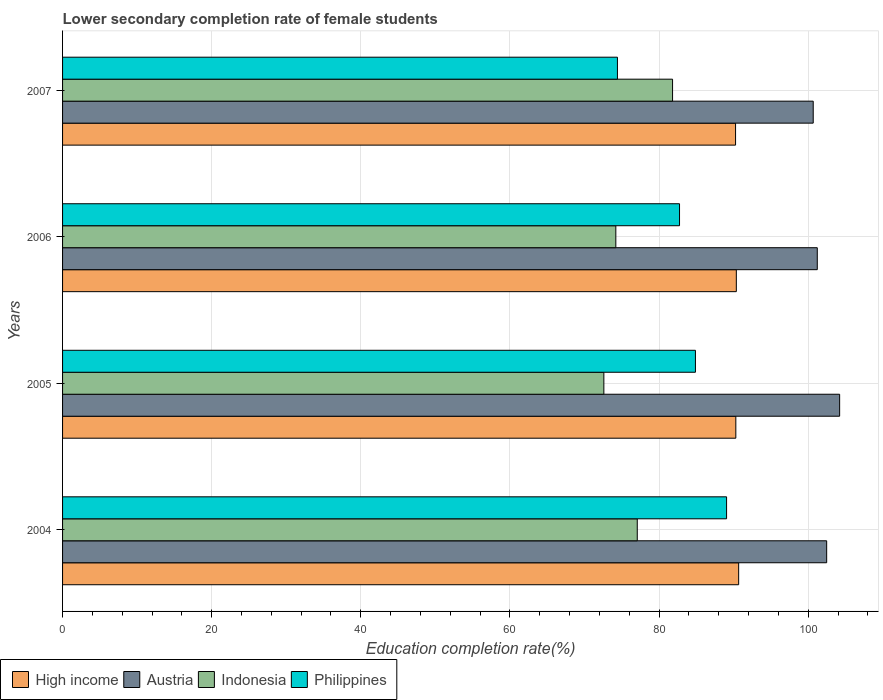How many bars are there on the 1st tick from the bottom?
Provide a succinct answer. 4. What is the label of the 1st group of bars from the top?
Your answer should be compact. 2007. What is the lower secondary completion rate of female students in Austria in 2004?
Your answer should be compact. 102.48. Across all years, what is the maximum lower secondary completion rate of female students in High income?
Provide a short and direct response. 90.67. Across all years, what is the minimum lower secondary completion rate of female students in Philippines?
Ensure brevity in your answer.  74.42. In which year was the lower secondary completion rate of female students in High income maximum?
Give a very brief answer. 2004. What is the total lower secondary completion rate of female students in High income in the graph?
Offer a terse response. 361.6. What is the difference between the lower secondary completion rate of female students in Philippines in 2004 and that in 2007?
Provide a succinct answer. 14.64. What is the difference between the lower secondary completion rate of female students in High income in 2004 and the lower secondary completion rate of female students in Indonesia in 2005?
Keep it short and to the point. 18.08. What is the average lower secondary completion rate of female students in High income per year?
Your answer should be compact. 90.4. In the year 2004, what is the difference between the lower secondary completion rate of female students in Indonesia and lower secondary completion rate of female students in Philippines?
Provide a succinct answer. -11.98. In how many years, is the lower secondary completion rate of female students in Philippines greater than 12 %?
Your response must be concise. 4. What is the ratio of the lower secondary completion rate of female students in Indonesia in 2004 to that in 2005?
Your answer should be very brief. 1.06. Is the lower secondary completion rate of female students in Austria in 2004 less than that in 2006?
Give a very brief answer. No. What is the difference between the highest and the second highest lower secondary completion rate of female students in Philippines?
Provide a succinct answer. 4.18. What is the difference between the highest and the lowest lower secondary completion rate of female students in Indonesia?
Make the answer very short. 9.21. Is the sum of the lower secondary completion rate of female students in High income in 2005 and 2007 greater than the maximum lower secondary completion rate of female students in Indonesia across all years?
Provide a succinct answer. Yes. What does the 3rd bar from the bottom in 2004 represents?
Provide a short and direct response. Indonesia. Is it the case that in every year, the sum of the lower secondary completion rate of female students in Austria and lower secondary completion rate of female students in High income is greater than the lower secondary completion rate of female students in Indonesia?
Provide a succinct answer. Yes. How many bars are there?
Provide a short and direct response. 16. Are the values on the major ticks of X-axis written in scientific E-notation?
Ensure brevity in your answer.  No. Does the graph contain any zero values?
Your response must be concise. No. Does the graph contain grids?
Keep it short and to the point. Yes. What is the title of the graph?
Provide a succinct answer. Lower secondary completion rate of female students. What is the label or title of the X-axis?
Provide a short and direct response. Education completion rate(%). What is the Education completion rate(%) of High income in 2004?
Your response must be concise. 90.67. What is the Education completion rate(%) of Austria in 2004?
Offer a very short reply. 102.48. What is the Education completion rate(%) of Indonesia in 2004?
Offer a very short reply. 77.08. What is the Education completion rate(%) of Philippines in 2004?
Offer a terse response. 89.05. What is the Education completion rate(%) of High income in 2005?
Keep it short and to the point. 90.3. What is the Education completion rate(%) of Austria in 2005?
Provide a short and direct response. 104.22. What is the Education completion rate(%) of Indonesia in 2005?
Provide a succinct answer. 72.6. What is the Education completion rate(%) in Philippines in 2005?
Your response must be concise. 84.88. What is the Education completion rate(%) in High income in 2006?
Ensure brevity in your answer.  90.36. What is the Education completion rate(%) of Austria in 2006?
Your response must be concise. 101.22. What is the Education completion rate(%) in Indonesia in 2006?
Your response must be concise. 74.2. What is the Education completion rate(%) of Philippines in 2006?
Your answer should be very brief. 82.75. What is the Education completion rate(%) in High income in 2007?
Your answer should be compact. 90.26. What is the Education completion rate(%) of Austria in 2007?
Ensure brevity in your answer.  100.68. What is the Education completion rate(%) in Indonesia in 2007?
Provide a short and direct response. 81.81. What is the Education completion rate(%) of Philippines in 2007?
Give a very brief answer. 74.42. Across all years, what is the maximum Education completion rate(%) of High income?
Your answer should be very brief. 90.67. Across all years, what is the maximum Education completion rate(%) of Austria?
Offer a terse response. 104.22. Across all years, what is the maximum Education completion rate(%) in Indonesia?
Give a very brief answer. 81.81. Across all years, what is the maximum Education completion rate(%) of Philippines?
Your response must be concise. 89.05. Across all years, what is the minimum Education completion rate(%) in High income?
Your answer should be very brief. 90.26. Across all years, what is the minimum Education completion rate(%) in Austria?
Offer a terse response. 100.68. Across all years, what is the minimum Education completion rate(%) of Indonesia?
Offer a very short reply. 72.6. Across all years, what is the minimum Education completion rate(%) of Philippines?
Ensure brevity in your answer.  74.42. What is the total Education completion rate(%) of High income in the graph?
Keep it short and to the point. 361.6. What is the total Education completion rate(%) in Austria in the graph?
Your answer should be very brief. 408.6. What is the total Education completion rate(%) in Indonesia in the graph?
Provide a short and direct response. 305.69. What is the total Education completion rate(%) in Philippines in the graph?
Ensure brevity in your answer.  331.1. What is the difference between the Education completion rate(%) of High income in 2004 and that in 2005?
Ensure brevity in your answer.  0.38. What is the difference between the Education completion rate(%) of Austria in 2004 and that in 2005?
Provide a succinct answer. -1.74. What is the difference between the Education completion rate(%) in Indonesia in 2004 and that in 2005?
Offer a very short reply. 4.48. What is the difference between the Education completion rate(%) in Philippines in 2004 and that in 2005?
Provide a succinct answer. 4.18. What is the difference between the Education completion rate(%) in High income in 2004 and that in 2006?
Offer a terse response. 0.31. What is the difference between the Education completion rate(%) of Austria in 2004 and that in 2006?
Offer a very short reply. 1.26. What is the difference between the Education completion rate(%) in Indonesia in 2004 and that in 2006?
Provide a succinct answer. 2.88. What is the difference between the Education completion rate(%) of Philippines in 2004 and that in 2006?
Offer a terse response. 6.31. What is the difference between the Education completion rate(%) of High income in 2004 and that in 2007?
Keep it short and to the point. 0.41. What is the difference between the Education completion rate(%) of Austria in 2004 and that in 2007?
Offer a very short reply. 1.8. What is the difference between the Education completion rate(%) of Indonesia in 2004 and that in 2007?
Give a very brief answer. -4.73. What is the difference between the Education completion rate(%) of Philippines in 2004 and that in 2007?
Offer a terse response. 14.64. What is the difference between the Education completion rate(%) in High income in 2005 and that in 2006?
Give a very brief answer. -0.07. What is the difference between the Education completion rate(%) of Austria in 2005 and that in 2006?
Give a very brief answer. 3. What is the difference between the Education completion rate(%) in Indonesia in 2005 and that in 2006?
Keep it short and to the point. -1.6. What is the difference between the Education completion rate(%) in Philippines in 2005 and that in 2006?
Provide a short and direct response. 2.13. What is the difference between the Education completion rate(%) in High income in 2005 and that in 2007?
Give a very brief answer. 0.03. What is the difference between the Education completion rate(%) in Austria in 2005 and that in 2007?
Your response must be concise. 3.54. What is the difference between the Education completion rate(%) of Indonesia in 2005 and that in 2007?
Your answer should be very brief. -9.21. What is the difference between the Education completion rate(%) in Philippines in 2005 and that in 2007?
Give a very brief answer. 10.46. What is the difference between the Education completion rate(%) of High income in 2006 and that in 2007?
Provide a short and direct response. 0.1. What is the difference between the Education completion rate(%) of Austria in 2006 and that in 2007?
Keep it short and to the point. 0.54. What is the difference between the Education completion rate(%) of Indonesia in 2006 and that in 2007?
Ensure brevity in your answer.  -7.61. What is the difference between the Education completion rate(%) in Philippines in 2006 and that in 2007?
Offer a very short reply. 8.33. What is the difference between the Education completion rate(%) in High income in 2004 and the Education completion rate(%) in Austria in 2005?
Ensure brevity in your answer.  -13.54. What is the difference between the Education completion rate(%) in High income in 2004 and the Education completion rate(%) in Indonesia in 2005?
Give a very brief answer. 18.08. What is the difference between the Education completion rate(%) of High income in 2004 and the Education completion rate(%) of Philippines in 2005?
Your response must be concise. 5.8. What is the difference between the Education completion rate(%) of Austria in 2004 and the Education completion rate(%) of Indonesia in 2005?
Your response must be concise. 29.88. What is the difference between the Education completion rate(%) of Austria in 2004 and the Education completion rate(%) of Philippines in 2005?
Make the answer very short. 17.6. What is the difference between the Education completion rate(%) in Indonesia in 2004 and the Education completion rate(%) in Philippines in 2005?
Your answer should be very brief. -7.8. What is the difference between the Education completion rate(%) in High income in 2004 and the Education completion rate(%) in Austria in 2006?
Ensure brevity in your answer.  -10.55. What is the difference between the Education completion rate(%) of High income in 2004 and the Education completion rate(%) of Indonesia in 2006?
Make the answer very short. 16.47. What is the difference between the Education completion rate(%) in High income in 2004 and the Education completion rate(%) in Philippines in 2006?
Ensure brevity in your answer.  7.93. What is the difference between the Education completion rate(%) of Austria in 2004 and the Education completion rate(%) of Indonesia in 2006?
Ensure brevity in your answer.  28.28. What is the difference between the Education completion rate(%) in Austria in 2004 and the Education completion rate(%) in Philippines in 2006?
Offer a very short reply. 19.73. What is the difference between the Education completion rate(%) in Indonesia in 2004 and the Education completion rate(%) in Philippines in 2006?
Provide a succinct answer. -5.67. What is the difference between the Education completion rate(%) in High income in 2004 and the Education completion rate(%) in Austria in 2007?
Your answer should be compact. -10. What is the difference between the Education completion rate(%) in High income in 2004 and the Education completion rate(%) in Indonesia in 2007?
Keep it short and to the point. 8.86. What is the difference between the Education completion rate(%) of High income in 2004 and the Education completion rate(%) of Philippines in 2007?
Your response must be concise. 16.26. What is the difference between the Education completion rate(%) in Austria in 2004 and the Education completion rate(%) in Indonesia in 2007?
Your answer should be very brief. 20.67. What is the difference between the Education completion rate(%) of Austria in 2004 and the Education completion rate(%) of Philippines in 2007?
Provide a succinct answer. 28.06. What is the difference between the Education completion rate(%) in Indonesia in 2004 and the Education completion rate(%) in Philippines in 2007?
Provide a short and direct response. 2.66. What is the difference between the Education completion rate(%) of High income in 2005 and the Education completion rate(%) of Austria in 2006?
Offer a terse response. -10.92. What is the difference between the Education completion rate(%) of High income in 2005 and the Education completion rate(%) of Indonesia in 2006?
Offer a very short reply. 16.09. What is the difference between the Education completion rate(%) of High income in 2005 and the Education completion rate(%) of Philippines in 2006?
Give a very brief answer. 7.55. What is the difference between the Education completion rate(%) of Austria in 2005 and the Education completion rate(%) of Indonesia in 2006?
Offer a very short reply. 30.02. What is the difference between the Education completion rate(%) in Austria in 2005 and the Education completion rate(%) in Philippines in 2006?
Ensure brevity in your answer.  21.47. What is the difference between the Education completion rate(%) of Indonesia in 2005 and the Education completion rate(%) of Philippines in 2006?
Ensure brevity in your answer.  -10.15. What is the difference between the Education completion rate(%) of High income in 2005 and the Education completion rate(%) of Austria in 2007?
Your answer should be very brief. -10.38. What is the difference between the Education completion rate(%) of High income in 2005 and the Education completion rate(%) of Indonesia in 2007?
Give a very brief answer. 8.49. What is the difference between the Education completion rate(%) in High income in 2005 and the Education completion rate(%) in Philippines in 2007?
Ensure brevity in your answer.  15.88. What is the difference between the Education completion rate(%) of Austria in 2005 and the Education completion rate(%) of Indonesia in 2007?
Offer a terse response. 22.41. What is the difference between the Education completion rate(%) in Austria in 2005 and the Education completion rate(%) in Philippines in 2007?
Your response must be concise. 29.8. What is the difference between the Education completion rate(%) in Indonesia in 2005 and the Education completion rate(%) in Philippines in 2007?
Provide a short and direct response. -1.82. What is the difference between the Education completion rate(%) of High income in 2006 and the Education completion rate(%) of Austria in 2007?
Make the answer very short. -10.31. What is the difference between the Education completion rate(%) of High income in 2006 and the Education completion rate(%) of Indonesia in 2007?
Your response must be concise. 8.55. What is the difference between the Education completion rate(%) in High income in 2006 and the Education completion rate(%) in Philippines in 2007?
Offer a very short reply. 15.95. What is the difference between the Education completion rate(%) of Austria in 2006 and the Education completion rate(%) of Indonesia in 2007?
Give a very brief answer. 19.41. What is the difference between the Education completion rate(%) in Austria in 2006 and the Education completion rate(%) in Philippines in 2007?
Make the answer very short. 26.8. What is the difference between the Education completion rate(%) in Indonesia in 2006 and the Education completion rate(%) in Philippines in 2007?
Keep it short and to the point. -0.22. What is the average Education completion rate(%) in High income per year?
Keep it short and to the point. 90.4. What is the average Education completion rate(%) of Austria per year?
Your answer should be very brief. 102.15. What is the average Education completion rate(%) in Indonesia per year?
Ensure brevity in your answer.  76.42. What is the average Education completion rate(%) in Philippines per year?
Make the answer very short. 82.77. In the year 2004, what is the difference between the Education completion rate(%) in High income and Education completion rate(%) in Austria?
Give a very brief answer. -11.81. In the year 2004, what is the difference between the Education completion rate(%) of High income and Education completion rate(%) of Indonesia?
Provide a short and direct response. 13.6. In the year 2004, what is the difference between the Education completion rate(%) of High income and Education completion rate(%) of Philippines?
Make the answer very short. 1.62. In the year 2004, what is the difference between the Education completion rate(%) of Austria and Education completion rate(%) of Indonesia?
Offer a very short reply. 25.4. In the year 2004, what is the difference between the Education completion rate(%) of Austria and Education completion rate(%) of Philippines?
Make the answer very short. 13.43. In the year 2004, what is the difference between the Education completion rate(%) in Indonesia and Education completion rate(%) in Philippines?
Offer a terse response. -11.98. In the year 2005, what is the difference between the Education completion rate(%) in High income and Education completion rate(%) in Austria?
Ensure brevity in your answer.  -13.92. In the year 2005, what is the difference between the Education completion rate(%) of High income and Education completion rate(%) of Indonesia?
Give a very brief answer. 17.7. In the year 2005, what is the difference between the Education completion rate(%) in High income and Education completion rate(%) in Philippines?
Keep it short and to the point. 5.42. In the year 2005, what is the difference between the Education completion rate(%) of Austria and Education completion rate(%) of Indonesia?
Give a very brief answer. 31.62. In the year 2005, what is the difference between the Education completion rate(%) in Austria and Education completion rate(%) in Philippines?
Offer a terse response. 19.34. In the year 2005, what is the difference between the Education completion rate(%) of Indonesia and Education completion rate(%) of Philippines?
Ensure brevity in your answer.  -12.28. In the year 2006, what is the difference between the Education completion rate(%) in High income and Education completion rate(%) in Austria?
Give a very brief answer. -10.86. In the year 2006, what is the difference between the Education completion rate(%) in High income and Education completion rate(%) in Indonesia?
Your response must be concise. 16.16. In the year 2006, what is the difference between the Education completion rate(%) in High income and Education completion rate(%) in Philippines?
Your answer should be compact. 7.62. In the year 2006, what is the difference between the Education completion rate(%) of Austria and Education completion rate(%) of Indonesia?
Provide a succinct answer. 27.02. In the year 2006, what is the difference between the Education completion rate(%) in Austria and Education completion rate(%) in Philippines?
Keep it short and to the point. 18.47. In the year 2006, what is the difference between the Education completion rate(%) in Indonesia and Education completion rate(%) in Philippines?
Provide a succinct answer. -8.54. In the year 2007, what is the difference between the Education completion rate(%) of High income and Education completion rate(%) of Austria?
Ensure brevity in your answer.  -10.41. In the year 2007, what is the difference between the Education completion rate(%) in High income and Education completion rate(%) in Indonesia?
Ensure brevity in your answer.  8.45. In the year 2007, what is the difference between the Education completion rate(%) in High income and Education completion rate(%) in Philippines?
Provide a short and direct response. 15.84. In the year 2007, what is the difference between the Education completion rate(%) of Austria and Education completion rate(%) of Indonesia?
Offer a terse response. 18.86. In the year 2007, what is the difference between the Education completion rate(%) of Austria and Education completion rate(%) of Philippines?
Offer a very short reply. 26.26. In the year 2007, what is the difference between the Education completion rate(%) of Indonesia and Education completion rate(%) of Philippines?
Make the answer very short. 7.39. What is the ratio of the Education completion rate(%) of Austria in 2004 to that in 2005?
Ensure brevity in your answer.  0.98. What is the ratio of the Education completion rate(%) in Indonesia in 2004 to that in 2005?
Keep it short and to the point. 1.06. What is the ratio of the Education completion rate(%) of Philippines in 2004 to that in 2005?
Offer a very short reply. 1.05. What is the ratio of the Education completion rate(%) of Austria in 2004 to that in 2006?
Provide a short and direct response. 1.01. What is the ratio of the Education completion rate(%) of Indonesia in 2004 to that in 2006?
Make the answer very short. 1.04. What is the ratio of the Education completion rate(%) in Philippines in 2004 to that in 2006?
Provide a succinct answer. 1.08. What is the ratio of the Education completion rate(%) in Austria in 2004 to that in 2007?
Your answer should be compact. 1.02. What is the ratio of the Education completion rate(%) in Indonesia in 2004 to that in 2007?
Offer a very short reply. 0.94. What is the ratio of the Education completion rate(%) of Philippines in 2004 to that in 2007?
Make the answer very short. 1.2. What is the ratio of the Education completion rate(%) of Austria in 2005 to that in 2006?
Ensure brevity in your answer.  1.03. What is the ratio of the Education completion rate(%) in Indonesia in 2005 to that in 2006?
Provide a short and direct response. 0.98. What is the ratio of the Education completion rate(%) in Philippines in 2005 to that in 2006?
Offer a very short reply. 1.03. What is the ratio of the Education completion rate(%) in Austria in 2005 to that in 2007?
Your answer should be very brief. 1.04. What is the ratio of the Education completion rate(%) in Indonesia in 2005 to that in 2007?
Provide a short and direct response. 0.89. What is the ratio of the Education completion rate(%) in Philippines in 2005 to that in 2007?
Offer a terse response. 1.14. What is the ratio of the Education completion rate(%) of High income in 2006 to that in 2007?
Your response must be concise. 1. What is the ratio of the Education completion rate(%) of Austria in 2006 to that in 2007?
Provide a short and direct response. 1.01. What is the ratio of the Education completion rate(%) of Indonesia in 2006 to that in 2007?
Ensure brevity in your answer.  0.91. What is the ratio of the Education completion rate(%) of Philippines in 2006 to that in 2007?
Ensure brevity in your answer.  1.11. What is the difference between the highest and the second highest Education completion rate(%) in High income?
Give a very brief answer. 0.31. What is the difference between the highest and the second highest Education completion rate(%) of Austria?
Keep it short and to the point. 1.74. What is the difference between the highest and the second highest Education completion rate(%) in Indonesia?
Provide a succinct answer. 4.73. What is the difference between the highest and the second highest Education completion rate(%) of Philippines?
Provide a short and direct response. 4.18. What is the difference between the highest and the lowest Education completion rate(%) of High income?
Ensure brevity in your answer.  0.41. What is the difference between the highest and the lowest Education completion rate(%) of Austria?
Ensure brevity in your answer.  3.54. What is the difference between the highest and the lowest Education completion rate(%) in Indonesia?
Your answer should be very brief. 9.21. What is the difference between the highest and the lowest Education completion rate(%) in Philippines?
Keep it short and to the point. 14.64. 